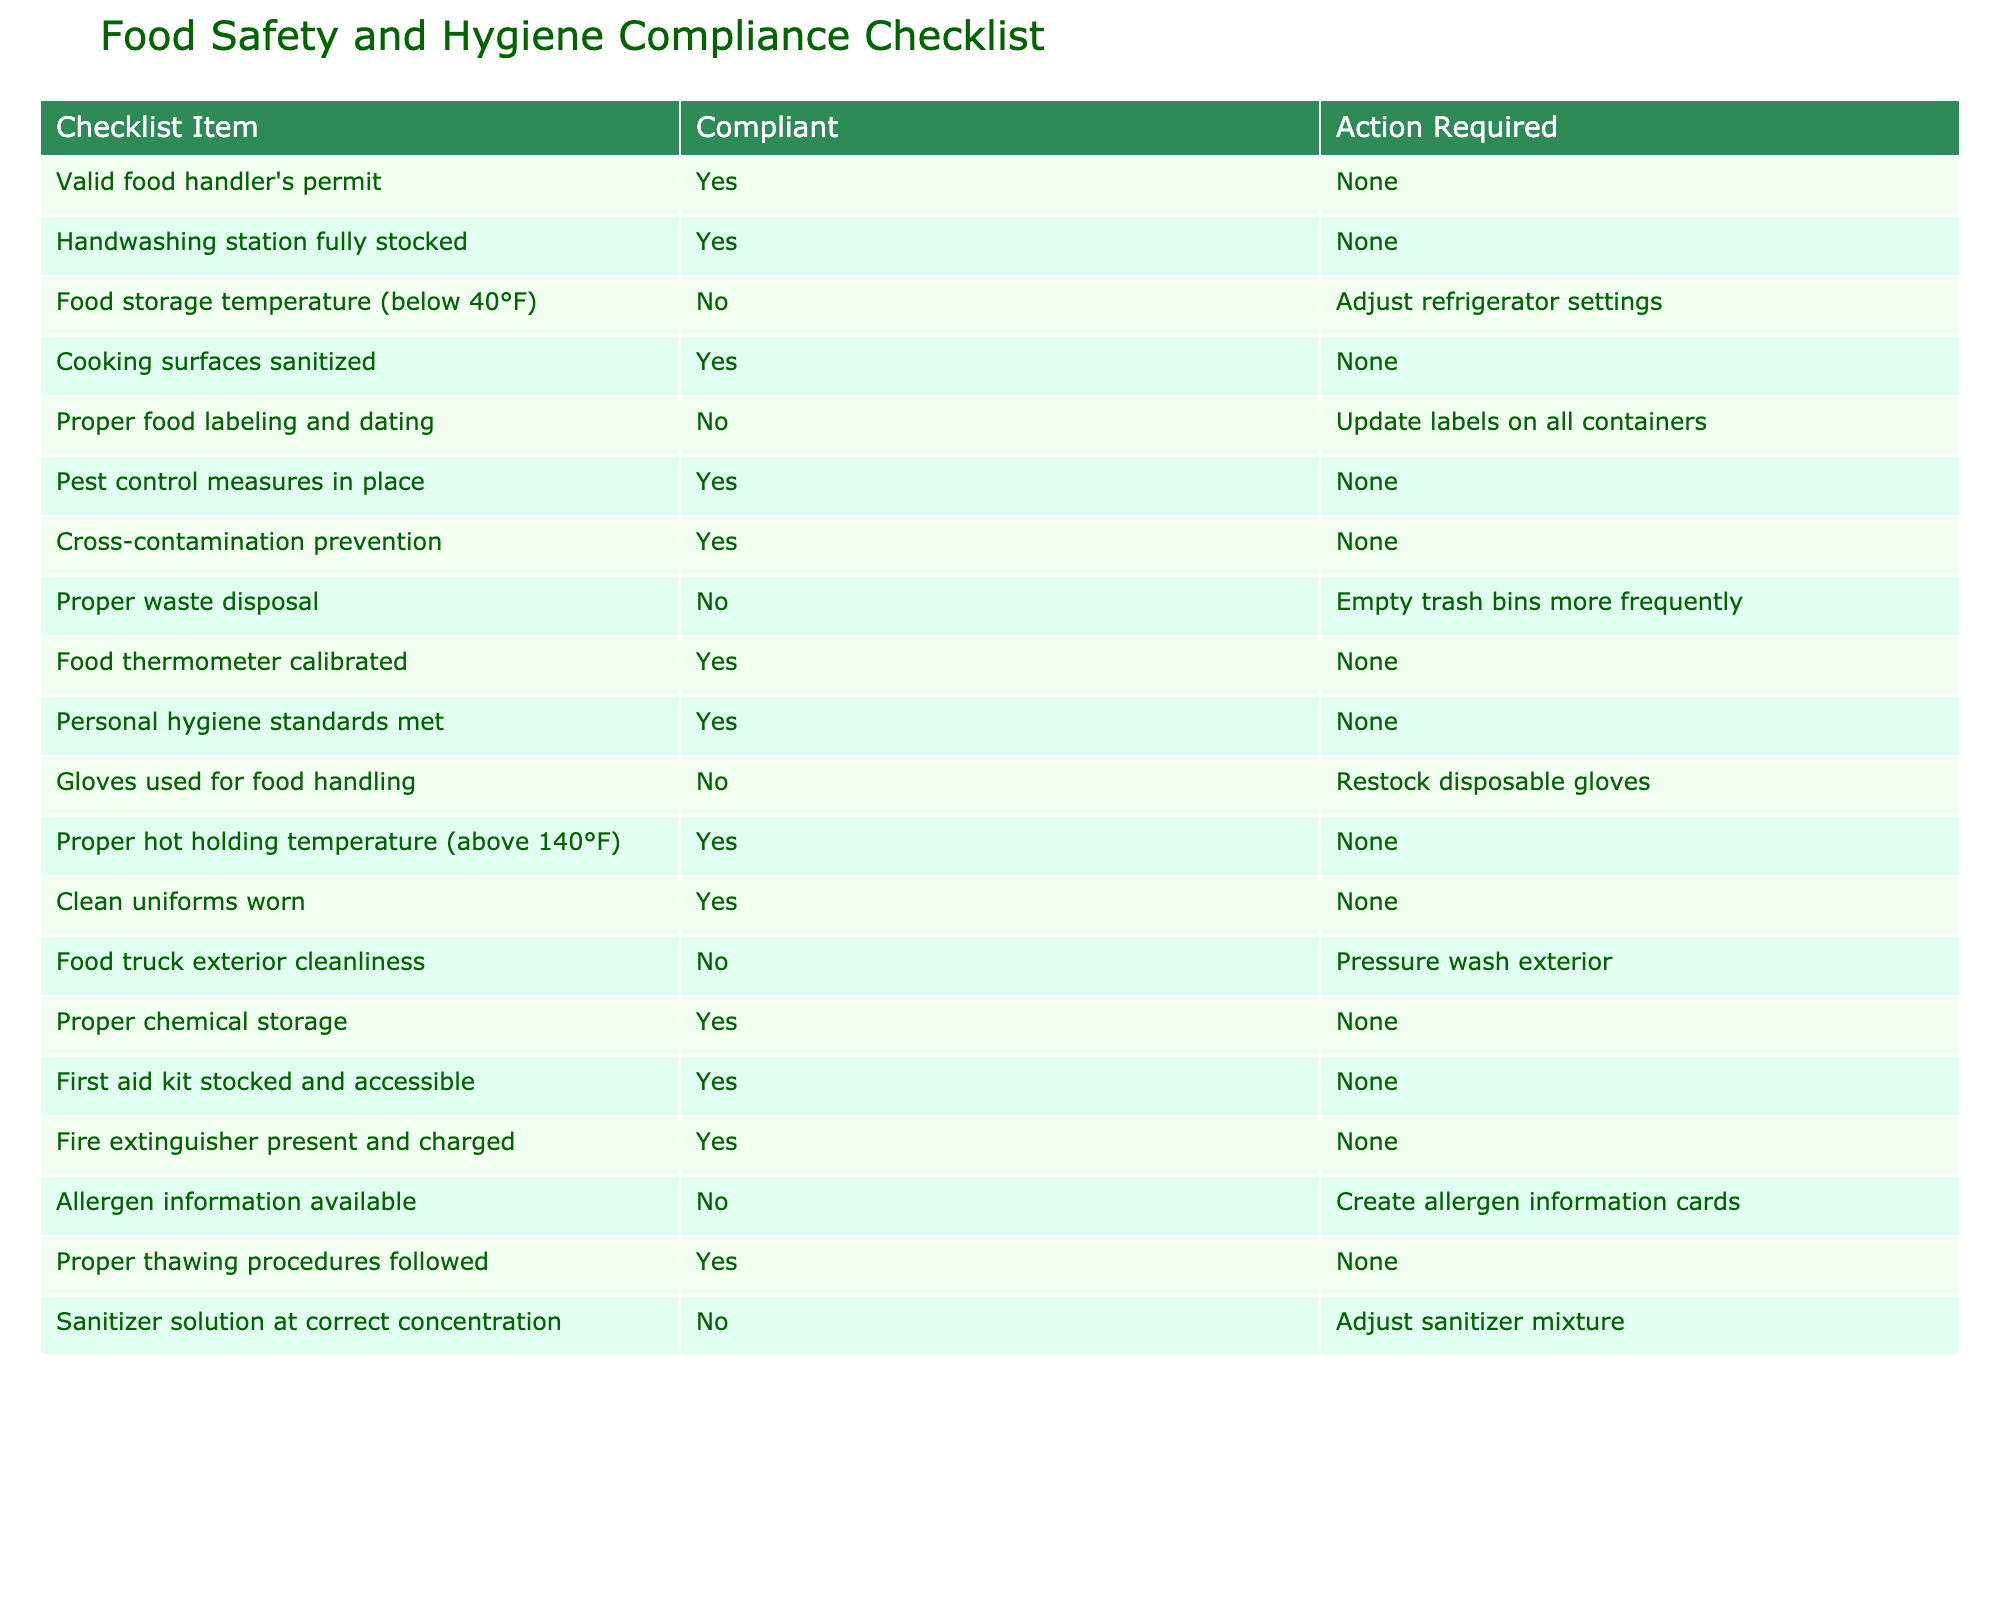What is the action required for maintaining proper food storage temperature? The table indicates that the food storage temperature is not compliant. The action required is to adjust refrigerator settings, which can be found in the row under that checklist item.
Answer: Adjust refrigerator settings How many checklist items are non-compliant? By counting the rows that indicate "No" under the Compliant column, there are 5 non-compliant checklist items: food storage temperature, proper food labeling and dating, proper waste disposal, gloves used for food handling, and food truck exterior cleanliness.
Answer: 5 Is the food thermometer calibrated? The checklist indicates that the food thermometer is compliant, as it states "Yes" in the Compliant column corresponding to this item.
Answer: Yes What actions are required to improve hygiene compliance based on the checklist? There are several actions required for improving hygiene compliance: update labels on all containers, empty trash bins more frequently, restock disposable gloves, pressure wash exterior, create allergen information cards, and adjust sanitizer mixture. These actions are taken from the checklist items that are marked as non-compliant.
Answer: Update labels, empty trash, restock gloves, pressure wash, create allergen cards, adjust sanitizer What percentage of checklist items are compliant? There are 6 compliant items out of 16 total items in the checklist. To find the percentage, calculate (6/16) * 100, which equals 37.5%.
Answer: 37.5% How many action items are required for proper personal hygiene standards? The table shows that the personal hygiene standards are compliant, indicated by a "Yes" in the Compliant column, so no action is required. Thus, there are zero action items related to this checklist item.
Answer: 0 What actions must be taken regarding pest control measures? The checklist shows that pest control measures are compliant, as indicated by a "Yes" in the Compliant column. Therefore, no action is required regarding pest control measures.
Answer: None Which item related to food storage could potentially lead to health risks if not addressed? The food storage temperature is listed as non-compliant and is crucial for food safety; if not adjusted to below 40°F, it could lead to foodborne illnesses, making it a potential health risk.
Answer: Food storage temperature 